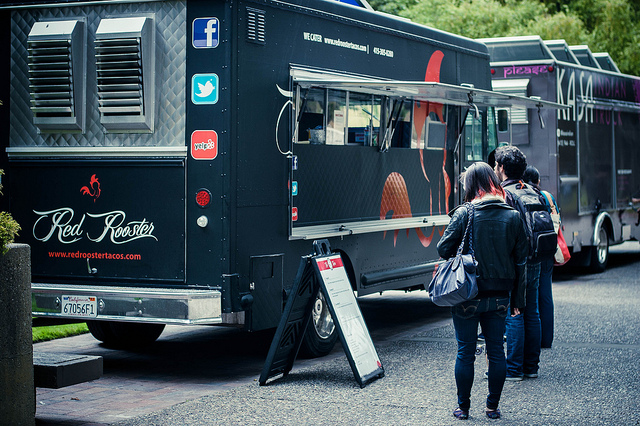Read and extract the text from this image. www.redroostertacos.com 67056F1 Red Rooster KASA YHF f 